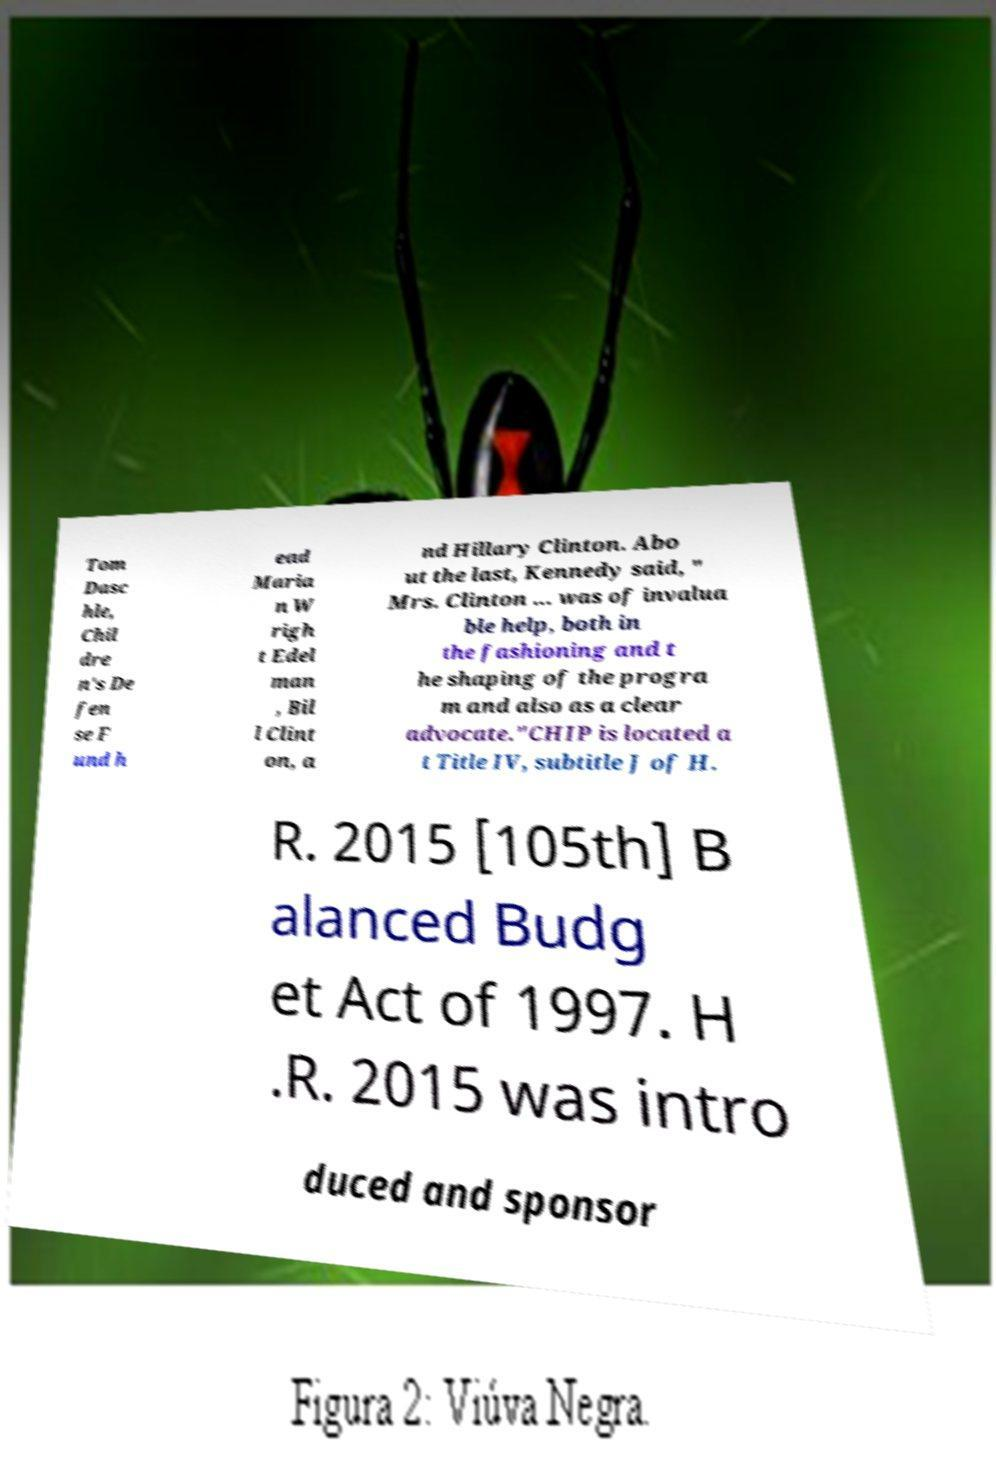For documentation purposes, I need the text within this image transcribed. Could you provide that? Tom Dasc hle, Chil dre n's De fen se F und h ead Maria n W righ t Edel man , Bil l Clint on, a nd Hillary Clinton. Abo ut the last, Kennedy said, " Mrs. Clinton ... was of invalua ble help, both in the fashioning and t he shaping of the progra m and also as a clear advocate."CHIP is located a t Title IV, subtitle J of H. R. 2015 [105th] B alanced Budg et Act of 1997. H .R. 2015 was intro duced and sponsor 